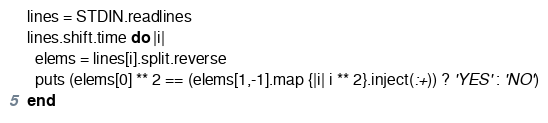<code> <loc_0><loc_0><loc_500><loc_500><_Ruby_>lines = STDIN.readlines
lines.shift.time do |i|
  elems = lines[i].split.reverse
  puts (elems[0] ** 2 == (elems[1,-1].map {|i| i ** 2}.inject(:+)) ? 'YES' : 'NO')
end</code> 